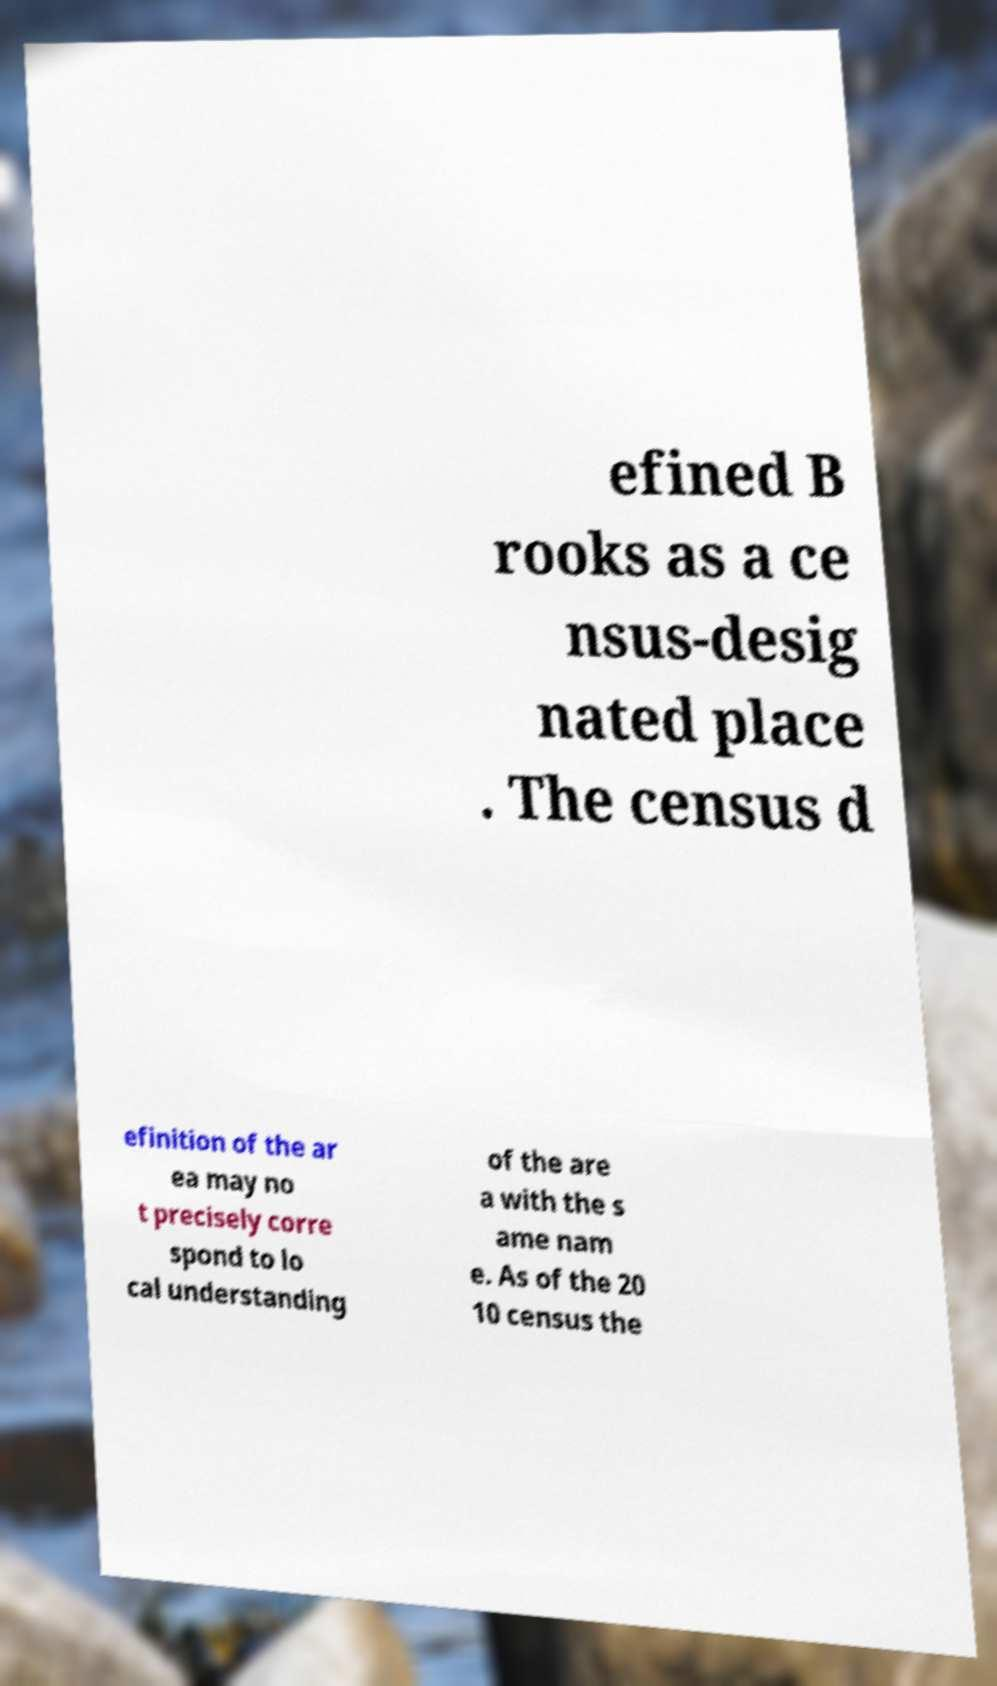Could you extract and type out the text from this image? efined B rooks as a ce nsus-desig nated place . The census d efinition of the ar ea may no t precisely corre spond to lo cal understanding of the are a with the s ame nam e. As of the 20 10 census the 